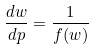Convert formula to latex. <formula><loc_0><loc_0><loc_500><loc_500>\frac { d w } { d p } = \frac { 1 } { f ( w ) }</formula> 